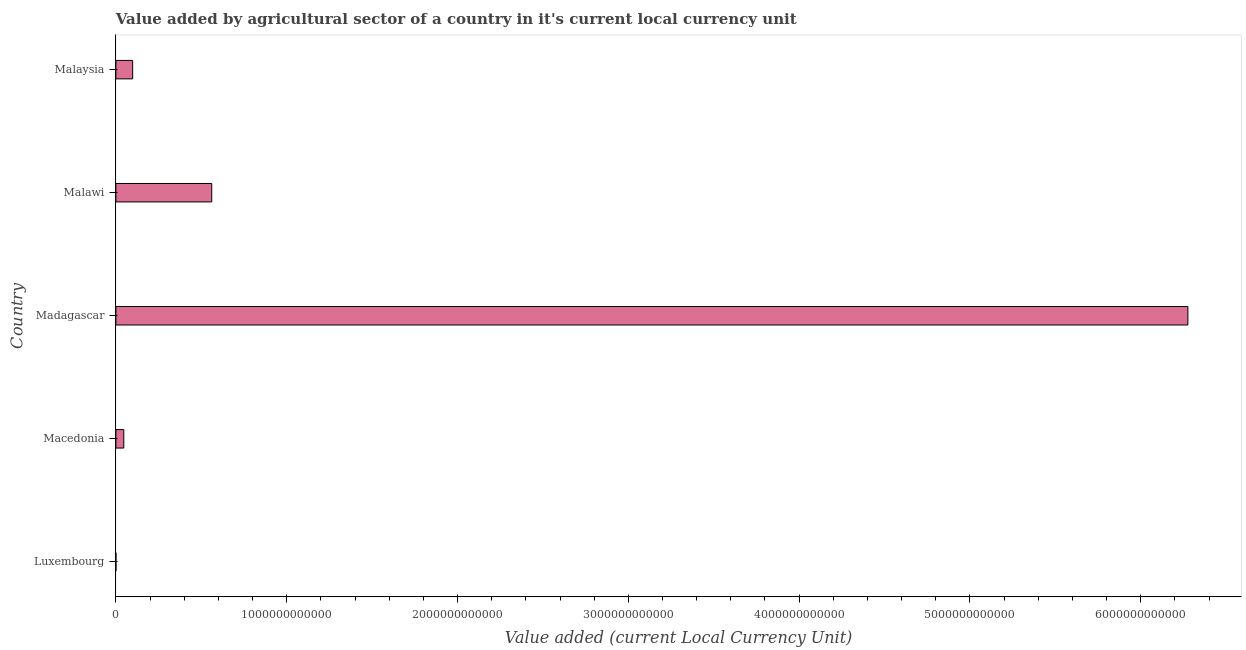Does the graph contain any zero values?
Offer a terse response. No. Does the graph contain grids?
Your answer should be very brief. No. What is the title of the graph?
Your answer should be very brief. Value added by agricultural sector of a country in it's current local currency unit. What is the label or title of the X-axis?
Your answer should be compact. Value added (current Local Currency Unit). What is the label or title of the Y-axis?
Offer a very short reply. Country. What is the value added by agriculture sector in Malaysia?
Keep it short and to the point. 9.82e+1. Across all countries, what is the maximum value added by agriculture sector?
Provide a succinct answer. 6.28e+12. Across all countries, what is the minimum value added by agriculture sector?
Offer a very short reply. 1.30e+08. In which country was the value added by agriculture sector maximum?
Make the answer very short. Madagascar. In which country was the value added by agriculture sector minimum?
Provide a succinct answer. Luxembourg. What is the sum of the value added by agriculture sector?
Provide a succinct answer. 6.98e+12. What is the difference between the value added by agriculture sector in Madagascar and Malawi?
Provide a short and direct response. 5.71e+12. What is the average value added by agriculture sector per country?
Your answer should be very brief. 1.40e+12. What is the median value added by agriculture sector?
Offer a terse response. 9.82e+1. What is the ratio of the value added by agriculture sector in Macedonia to that in Madagascar?
Your response must be concise. 0.01. Is the difference between the value added by agriculture sector in Malawi and Malaysia greater than the difference between any two countries?
Make the answer very short. No. What is the difference between the highest and the second highest value added by agriculture sector?
Your response must be concise. 5.71e+12. What is the difference between the highest and the lowest value added by agriculture sector?
Provide a succinct answer. 6.28e+12. How many bars are there?
Keep it short and to the point. 5. What is the difference between two consecutive major ticks on the X-axis?
Your answer should be compact. 1.00e+12. What is the Value added (current Local Currency Unit) of Luxembourg?
Provide a succinct answer. 1.30e+08. What is the Value added (current Local Currency Unit) in Macedonia?
Your answer should be very brief. 4.63e+1. What is the Value added (current Local Currency Unit) of Madagascar?
Your answer should be compact. 6.28e+12. What is the Value added (current Local Currency Unit) in Malawi?
Offer a very short reply. 5.61e+11. What is the Value added (current Local Currency Unit) in Malaysia?
Provide a succinct answer. 9.82e+1. What is the difference between the Value added (current Local Currency Unit) in Luxembourg and Macedonia?
Provide a succinct answer. -4.62e+1. What is the difference between the Value added (current Local Currency Unit) in Luxembourg and Madagascar?
Offer a very short reply. -6.28e+12. What is the difference between the Value added (current Local Currency Unit) in Luxembourg and Malawi?
Give a very brief answer. -5.61e+11. What is the difference between the Value added (current Local Currency Unit) in Luxembourg and Malaysia?
Provide a short and direct response. -9.80e+1. What is the difference between the Value added (current Local Currency Unit) in Macedonia and Madagascar?
Make the answer very short. -6.23e+12. What is the difference between the Value added (current Local Currency Unit) in Macedonia and Malawi?
Give a very brief answer. -5.15e+11. What is the difference between the Value added (current Local Currency Unit) in Macedonia and Malaysia?
Give a very brief answer. -5.19e+1. What is the difference between the Value added (current Local Currency Unit) in Madagascar and Malawi?
Give a very brief answer. 5.71e+12. What is the difference between the Value added (current Local Currency Unit) in Madagascar and Malaysia?
Your response must be concise. 6.18e+12. What is the difference between the Value added (current Local Currency Unit) in Malawi and Malaysia?
Ensure brevity in your answer.  4.63e+11. What is the ratio of the Value added (current Local Currency Unit) in Luxembourg to that in Macedonia?
Your answer should be very brief. 0. What is the ratio of the Value added (current Local Currency Unit) in Macedonia to that in Madagascar?
Give a very brief answer. 0.01. What is the ratio of the Value added (current Local Currency Unit) in Macedonia to that in Malawi?
Provide a short and direct response. 0.08. What is the ratio of the Value added (current Local Currency Unit) in Macedonia to that in Malaysia?
Provide a succinct answer. 0.47. What is the ratio of the Value added (current Local Currency Unit) in Madagascar to that in Malawi?
Offer a terse response. 11.18. What is the ratio of the Value added (current Local Currency Unit) in Madagascar to that in Malaysia?
Your response must be concise. 63.94. What is the ratio of the Value added (current Local Currency Unit) in Malawi to that in Malaysia?
Your answer should be very brief. 5.72. 